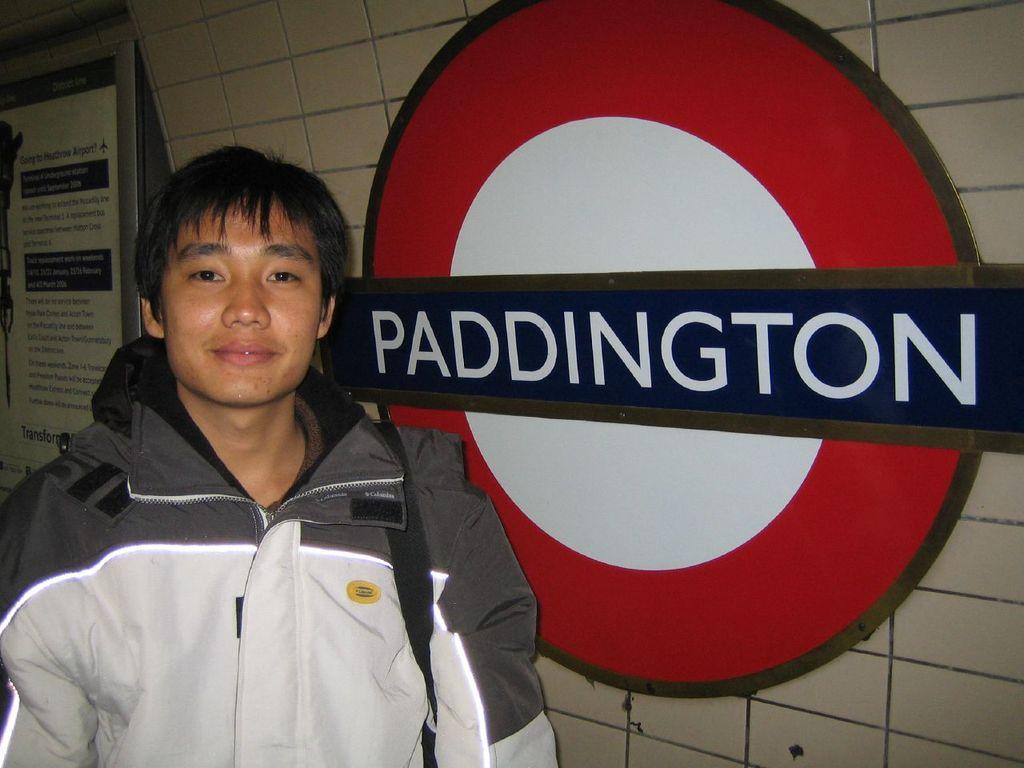<image>
Present a compact description of the photo's key features. A young man standing next to the Paddington train station sign having his picture taken. 